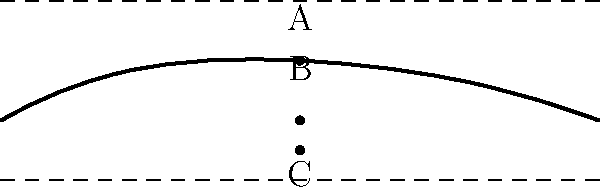Based on the cross-sectional view of an aircraft wing shown above, which point represents the center of pressure? To identify the center of pressure on an aircraft wing, we need to understand its aerodynamic properties:

1. The center of pressure is the point where the total sum of aerodynamic forces can be considered to act on the airfoil.

2. In a typical subsonic airfoil:
   a) The leading edge is rounded and thicker.
   b) The trailing edge is sharp and thinner.

3. The center of pressure is usually located approximately 1/4 of the chord length from the leading edge.

4. Examining the given cross-section:
   - Point A is too far forward, near the leading edge.
   - Point C is below the airfoil, which is not a possible location for the center of pressure.
   - Point B is located roughly 1/4 of the chord length from the leading edge, inside the airfoil.

5. Therefore, Point B most closely represents the typical location of the center of pressure on an aircraft wing.

This knowledge is crucial for aeronautical engineering students to understand the distribution of aerodynamic forces on aircraft wings and its implications for flight dynamics and structural design.
Answer: B 